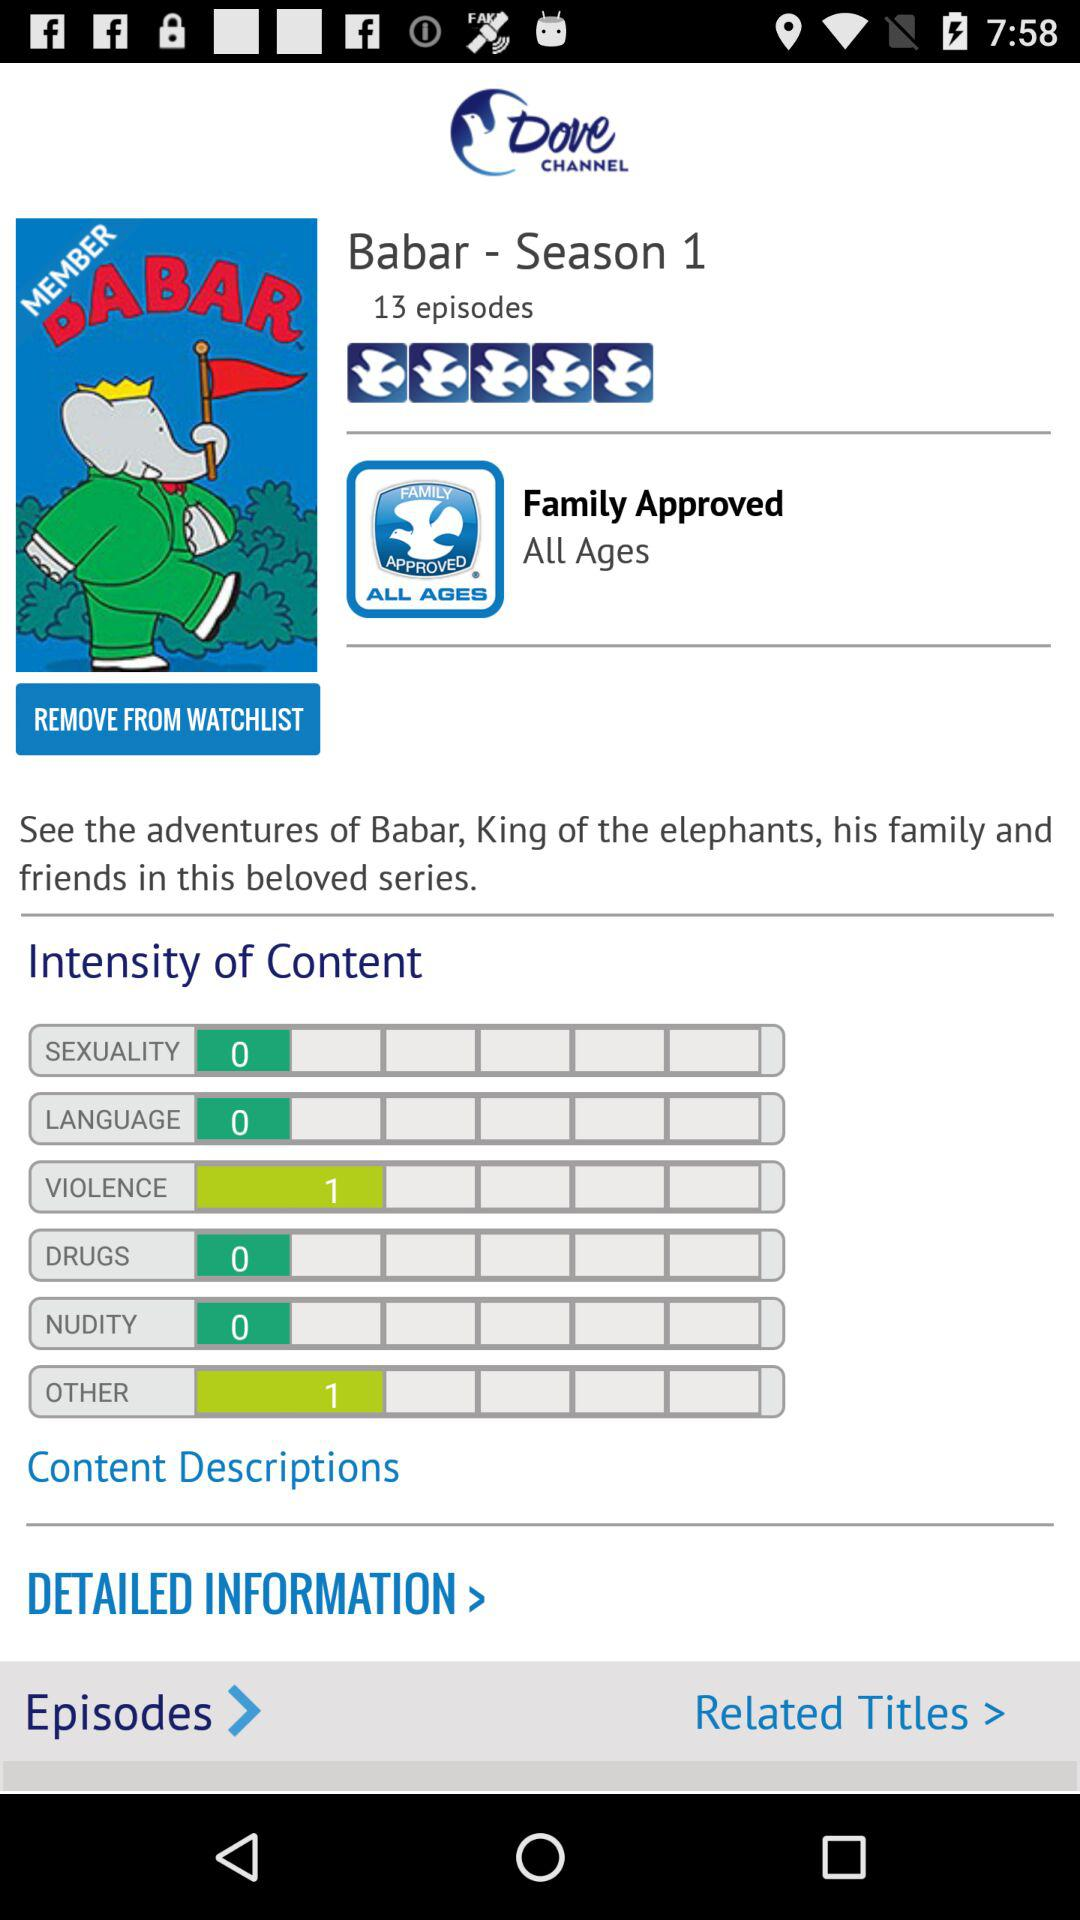Which season of the series has been released? There has been 1 season released of the series. 